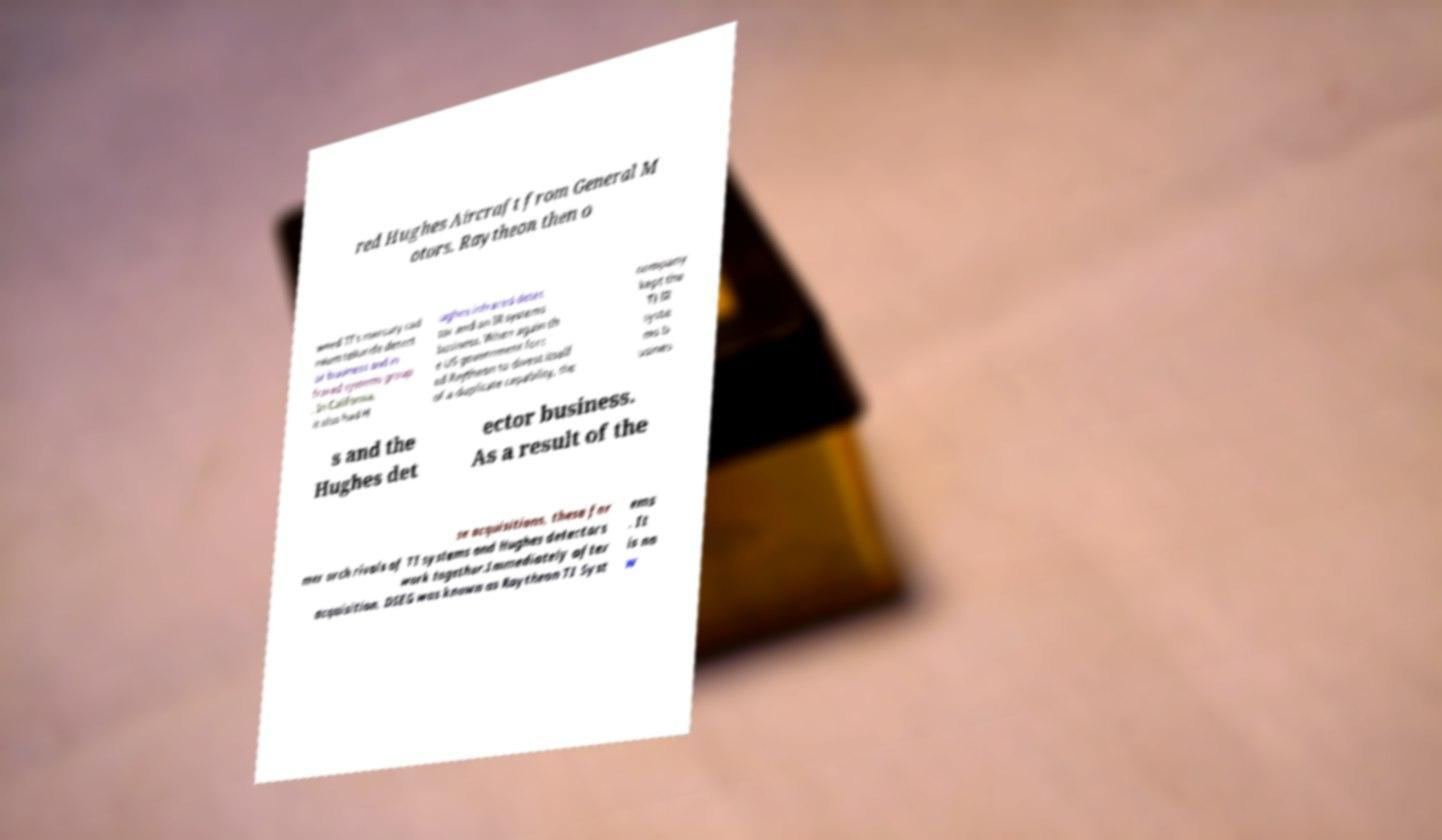I need the written content from this picture converted into text. Can you do that? red Hughes Aircraft from General M otors. Raytheon then o wned TI's mercury cad mium telluride detect or business and in frared systems group . In California, it also had H ughes infrared detec tor and an IR systems business. When again th e US government forc ed Raytheon to divest itself of a duplicate capability, the company kept the TI IR syste ms b usines s and the Hughes det ector business. As a result of the se acquisitions, these for mer arch rivals of TI systems and Hughes detectors work together.Immediately after acquisition, DSEG was known as Raytheon TI Syst ems . It is no w 